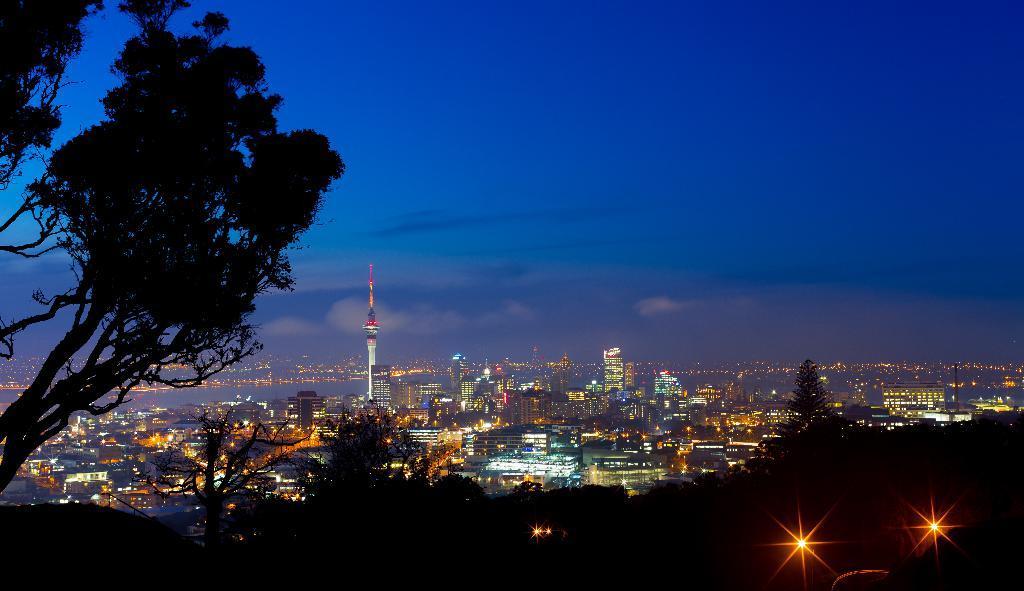Describe this image in one or two sentences. In this image we can see trees, buildings and a river. 